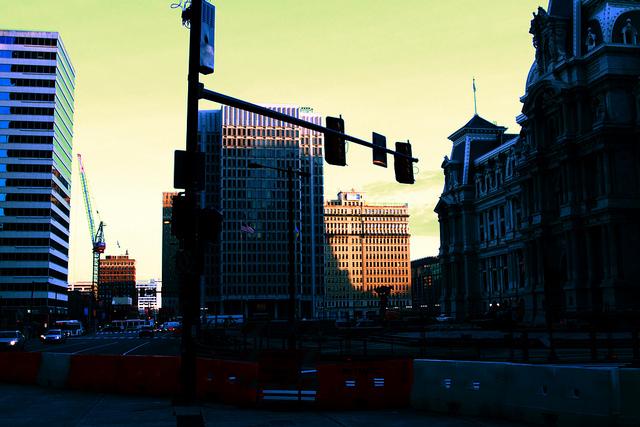Is there construction going on?
Write a very short answer. Yes. How many buildings are in the shot?
Answer briefly. 7. Is it dawn?
Give a very brief answer. Yes. 